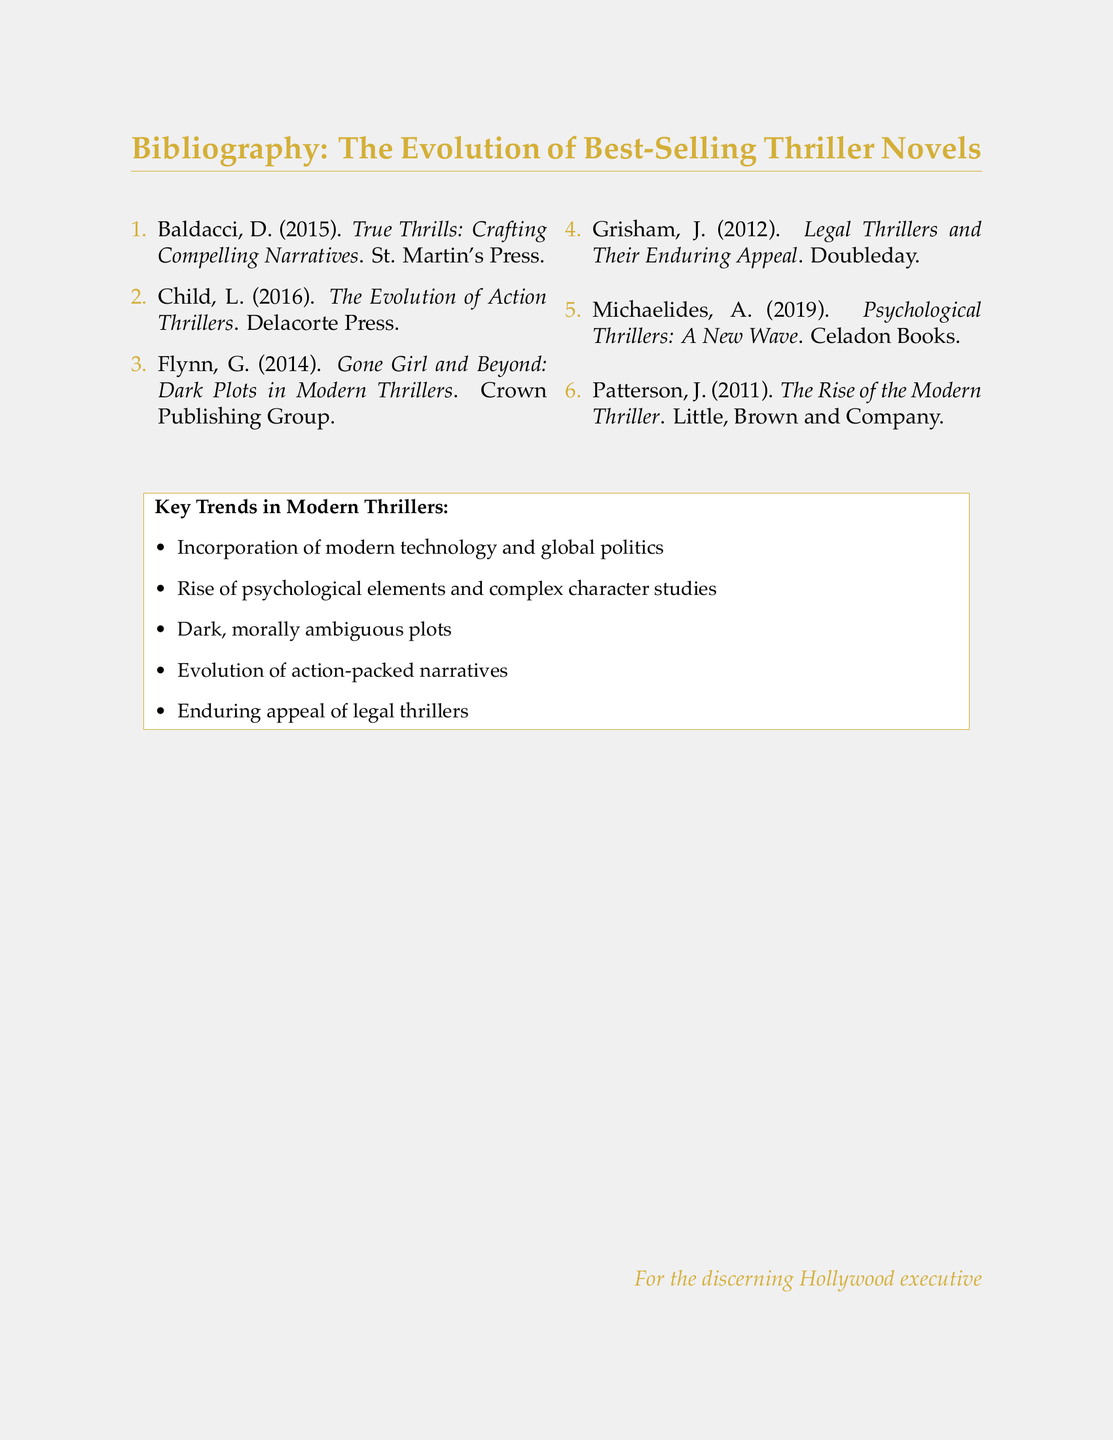What is the title of David Baldacci's book? The title is listed in the bibliography section under Baldacci's entry, which is "True Thrills: Crafting Compelling Narratives".
Answer: True Thrills: Crafting Compelling Narratives Who published "Gone Girl and Beyond: Dark Plots in Modern Thrillers"? The publisher's name is specified next to Flynn's book title in the bibliography, which is Crown Publishing Group.
Answer: Crown Publishing Group What year was "The Evolution of Action Thrillers" published? The year is included in the citation for Child's book in the bibliography, which is 2016.
Answer: 2016 What key trend emphasizes morally ambiguous plots? The trend is mentioned in the list of key trends in modern thrillers at the bottom of the document.
Answer: Dark, morally ambiguous plots How many authors are listed in the bibliography? The total number of entries in the enumerated list is counted to provide the answer. There are six authors listed.
Answer: 6 What genre does A. Michaelides' book focus on? The genre is indicated in the title of Michaelides' work listed in the bibliography, which is psychological thrillers.
Answer: Psychological Thrillers Which publisher released "The Rise of the Modern Thriller"? The publisher name is included next to Patterson's book title in the bibliography, which is Little, Brown and Company.
Answer: Little, Brown and Company What is a key element incorporated into modern thrillers? The element is highlighted in the list of key trends at the bottom of the document, which includes modern technology.
Answer: Modern technology 